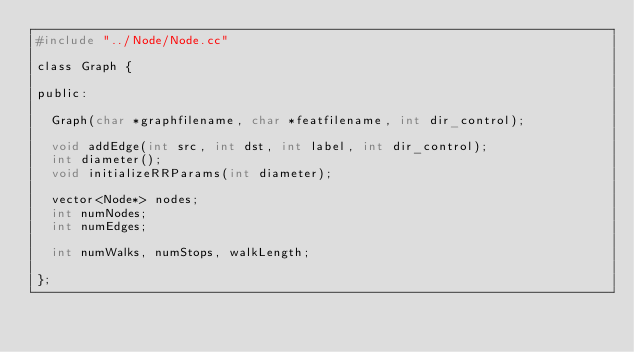<code> <loc_0><loc_0><loc_500><loc_500><_C_>#include "../Node/Node.cc"

class Graph {

public:

	Graph(char *graphfilename, char *featfilename, int dir_control);

	void addEdge(int src, int dst, int label, int dir_control); 
	int diameter(); 
	void initializeRRParams(int diameter); 

	vector<Node*> nodes; 
	int numNodes; 
	int numEdges; 

	int numWalks, numStops, walkLength; 

};

</code> 